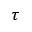<formula> <loc_0><loc_0><loc_500><loc_500>\tau</formula> 